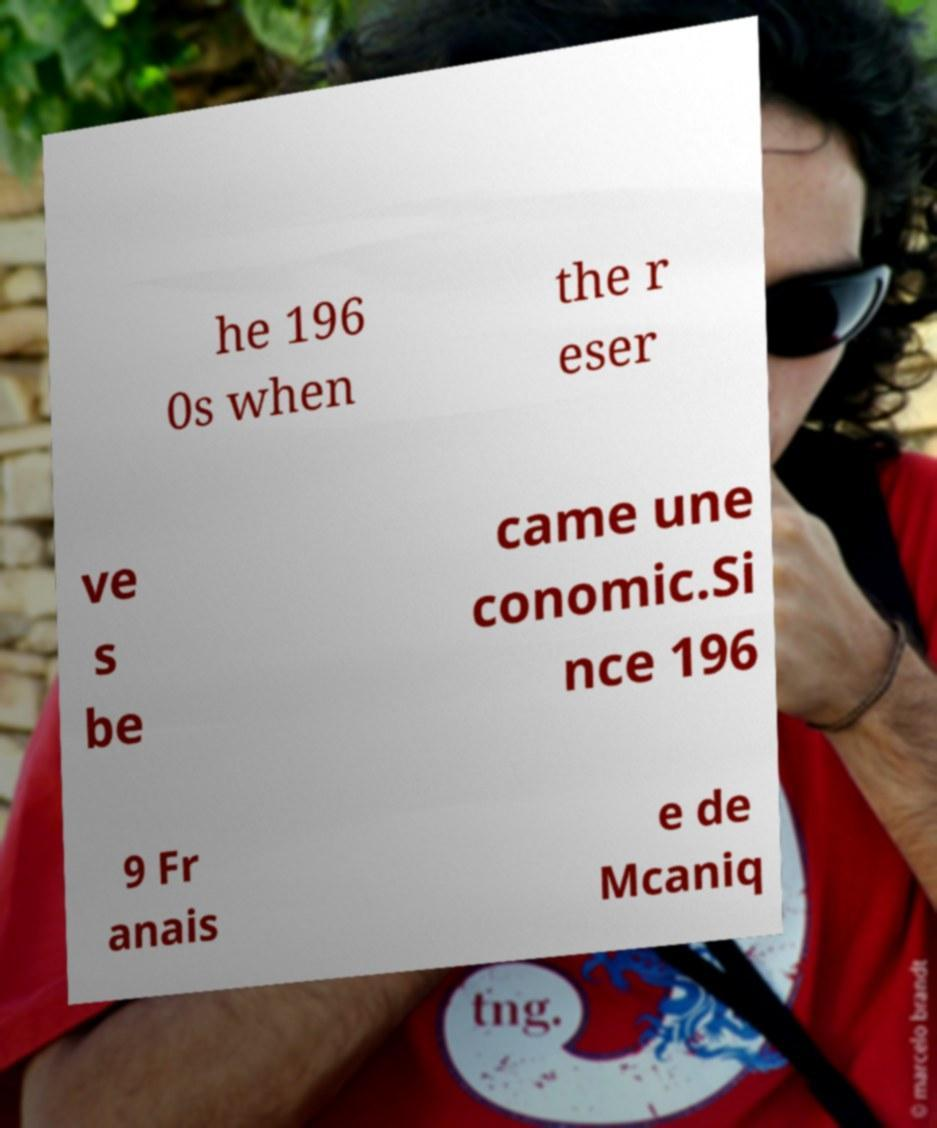I need the written content from this picture converted into text. Can you do that? he 196 0s when the r eser ve s be came une conomic.Si nce 196 9 Fr anais e de Mcaniq 